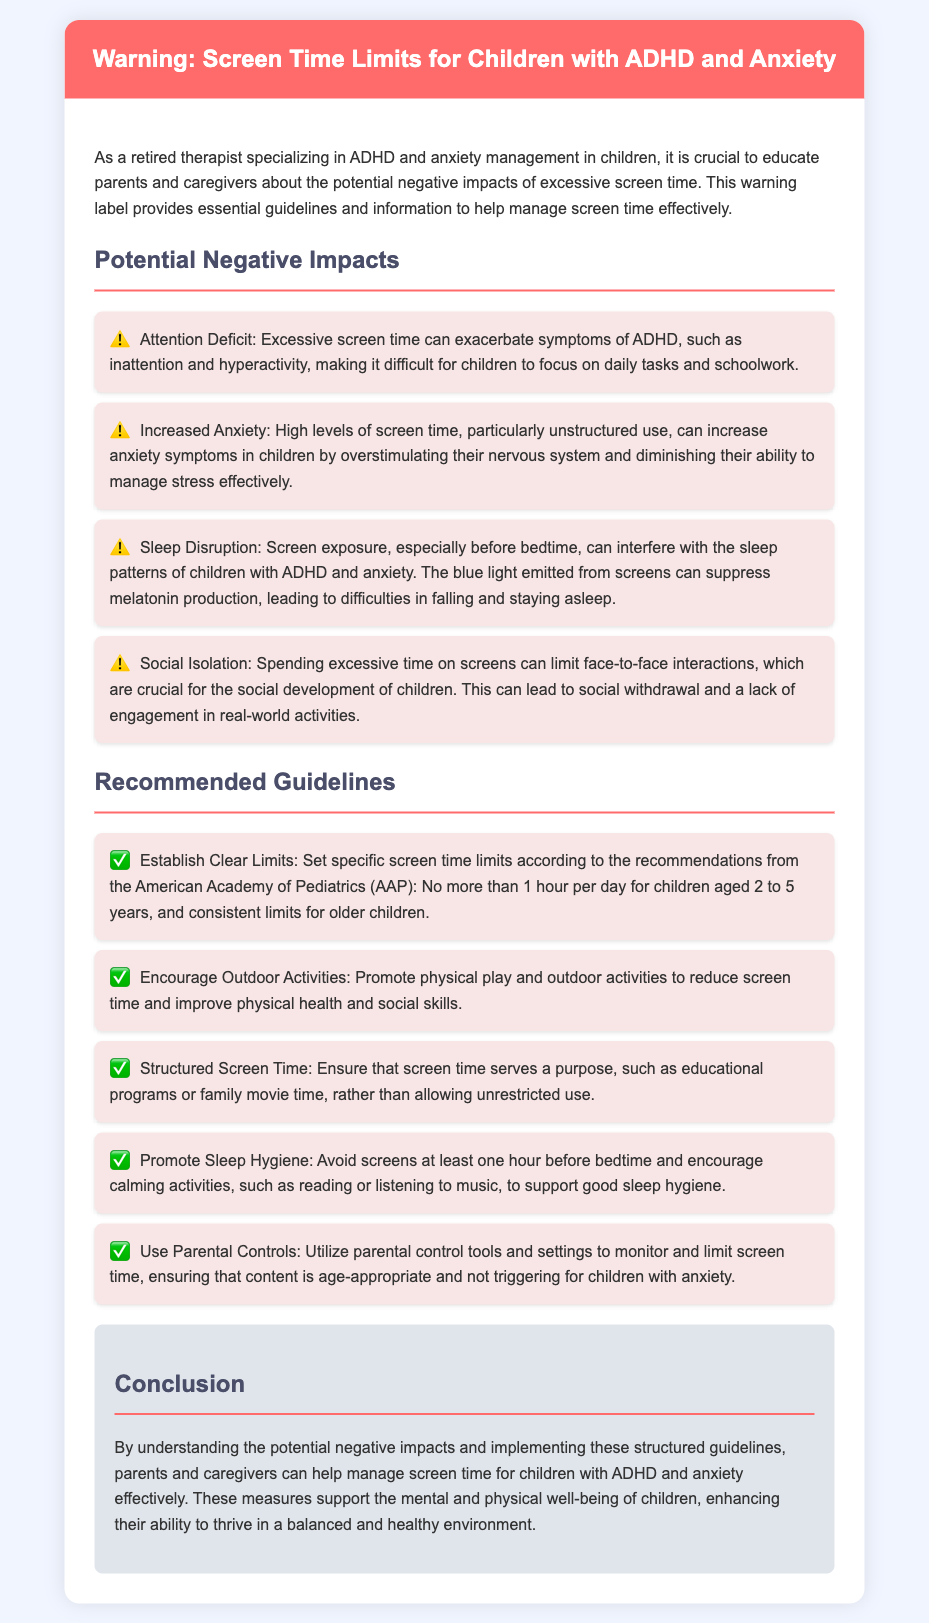What is the maximum recommended screen time for children aged 2 to 5 years? The document states that the American Academy of Pediatrics recommends no more than 1 hour per day for children aged 2 to 5 years.
Answer: 1 hour What can excessive screen time exacerbate in children? The document mentions that excessive screen time can exacerbate symptoms of ADHD, such as inattention and hyperactivity.
Answer: ADHD symptoms What does screen time do to children's sleep patterns? The document explains that screen exposure, especially before bedtime, can interfere with sleep patterns.
Answer: Interferes with sleep What is one activity recommended to reduce screen time? The document suggests promoting physical play and outdoor activities to reduce screen time.
Answer: Outdoor activities Why should screens be avoided before bedtime? The document states that screens should be avoided at least one hour before bedtime to support good sleep hygiene.
Answer: Support good sleep hygiene How does excessive screen time affect children's anxiety levels? The document indicates that high levels of screen time, particularly unstructured use, can increase anxiety symptoms in children.
Answer: Increase anxiety symptoms What tool can parents use to monitor and limit screen time? The document suggests utilizing parental control tools and settings to monitor and limit screen time.
Answer: Parental control tools What is the impact of excessive screen time on social interactions? The document mentions that spending excessive time on screens can limit face-to-face interactions, leading to social withdrawal.
Answer: Social withdrawal 